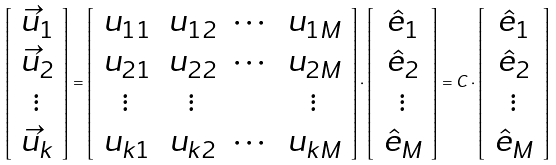Convert formula to latex. <formula><loc_0><loc_0><loc_500><loc_500>\left [ \begin{array} { c } \vec { u } _ { 1 } \\ \vec { u } _ { 2 } \\ \vdots \\ \vec { u } _ { k } \end{array} \right ] = \left [ \begin{array} { c c c c } u _ { 1 1 } & u _ { 1 2 } & \cdots & u _ { 1 M } \\ u _ { 2 1 } & u _ { 2 2 } & \cdots & u _ { 2 M } \\ \vdots & \vdots & & \vdots \\ u _ { k 1 } & u _ { k 2 } & \cdots & u _ { k M } \end{array} \right ] \cdot \left [ \begin{array} { c } \hat { e } _ { 1 } \\ \hat { e } _ { 2 } \\ \vdots \\ \hat { e } _ { M } \end{array} \right ] = C \cdot \left [ \begin{array} { c } \hat { e } _ { 1 } \\ \hat { e } _ { 2 } \\ \vdots \\ \hat { e } _ { M } \end{array} \right ] \,</formula> 